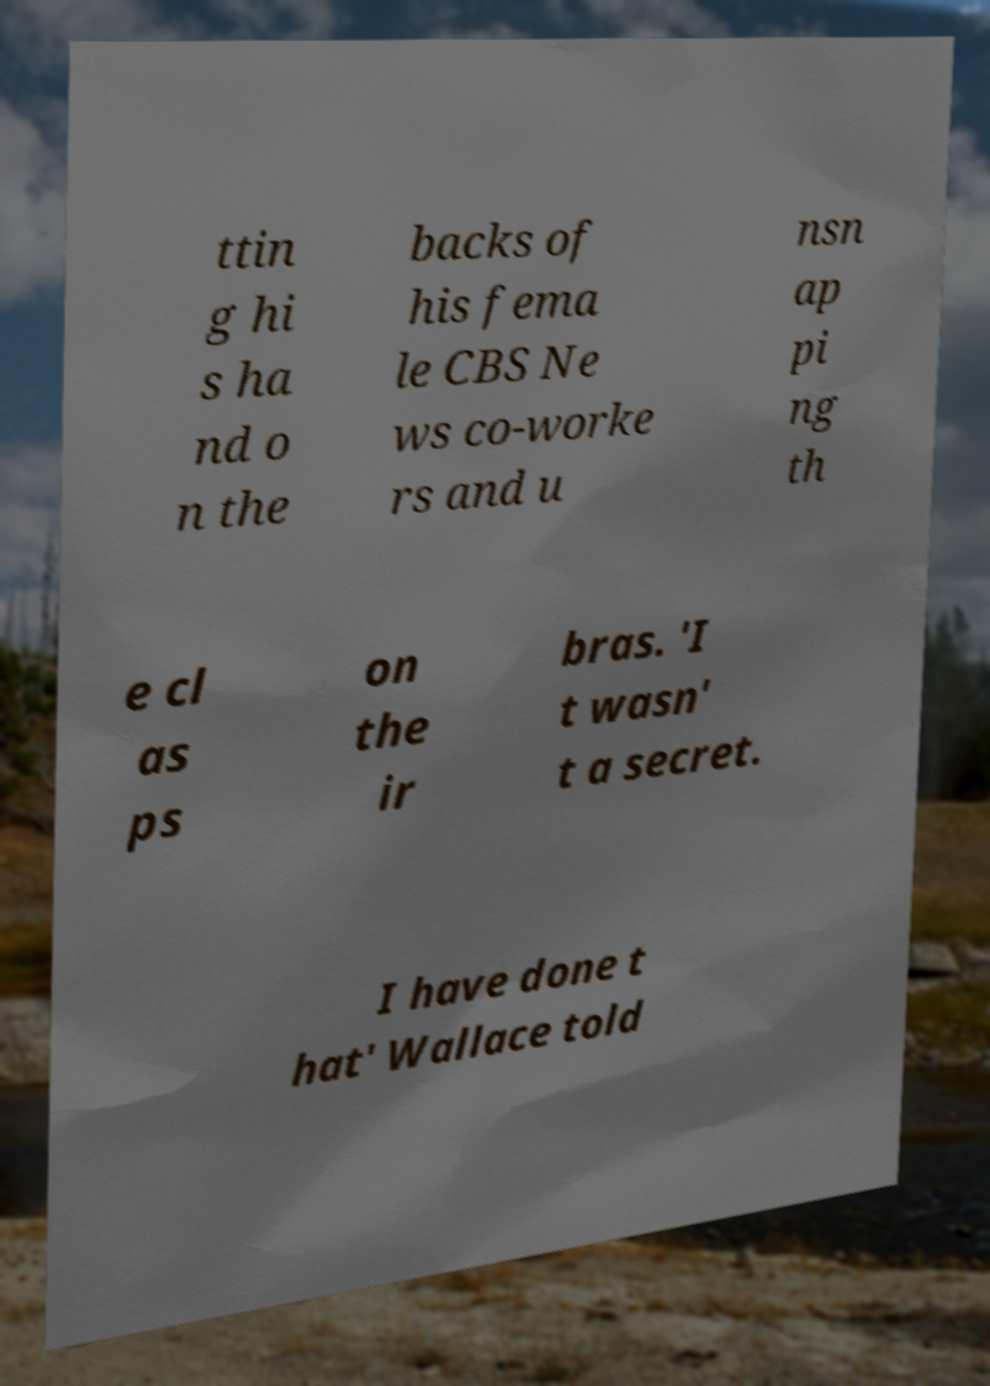Could you extract and type out the text from this image? ttin g hi s ha nd o n the backs of his fema le CBS Ne ws co-worke rs and u nsn ap pi ng th e cl as ps on the ir bras. 'I t wasn' t a secret. I have done t hat' Wallace told 